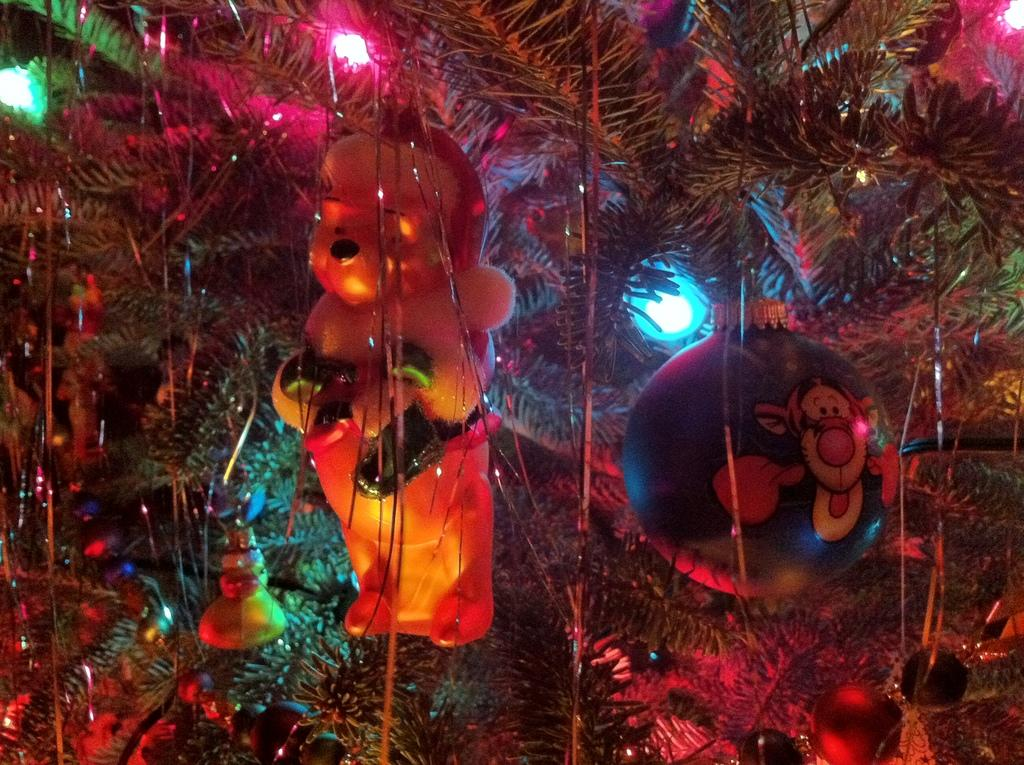What is located in the center of the image? There are toys in the center of the image. What type of objects can be seen in addition to the toys? There are balls in the image. What is being used to hold decoration items in the image? Decoration items are hanging on a tree in the image. What can be seen providing illumination in the image? Lights are visible in the image are visible. Can you describe any other objects present in the image? There are other objects in the image, but their specific details are not mentioned in the provided facts. What is the dog arguing with the visitor about in the image? There is no dog or visitor present in the image, so there can be no argument between them. 